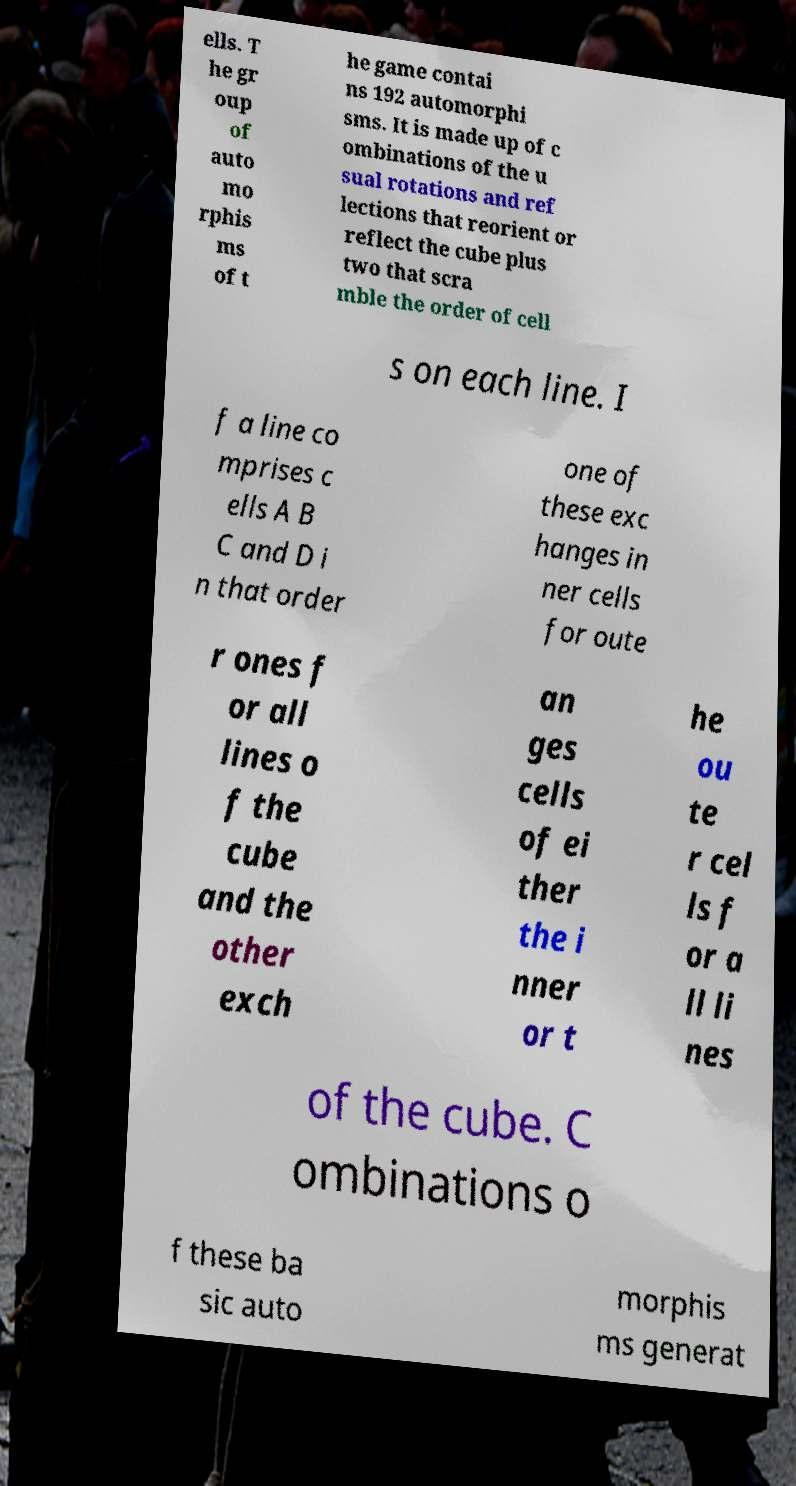Could you assist in decoding the text presented in this image and type it out clearly? ells. T he gr oup of auto mo rphis ms of t he game contai ns 192 automorphi sms. It is made up of c ombinations of the u sual rotations and ref lections that reorient or reflect the cube plus two that scra mble the order of cell s on each line. I f a line co mprises c ells A B C and D i n that order one of these exc hanges in ner cells for oute r ones f or all lines o f the cube and the other exch an ges cells of ei ther the i nner or t he ou te r cel ls f or a ll li nes of the cube. C ombinations o f these ba sic auto morphis ms generat 